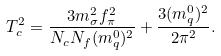<formula> <loc_0><loc_0><loc_500><loc_500>T _ { c } ^ { 2 } = \frac { 3 m _ { \sigma } ^ { 2 } f _ { \pi } ^ { 2 } } { N _ { c } N _ { f } ( m _ { q } ^ { 0 } ) ^ { 2 } } + \frac { 3 ( m _ { q } ^ { 0 } ) ^ { 2 } } { 2 \pi ^ { 2 } } .</formula> 